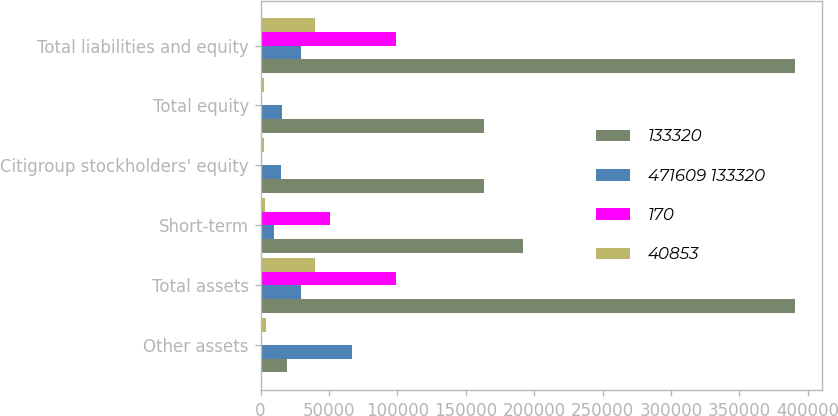Convert chart to OTSL. <chart><loc_0><loc_0><loc_500><loc_500><stacked_bar_chart><ecel><fcel>Other assets<fcel>Total assets<fcel>Short-term<fcel>Citigroup stockholders' equity<fcel>Total equity<fcel>Total liabilities and equity<nl><fcel>133320<fcel>19572<fcel>390607<fcel>191944<fcel>163468<fcel>163468<fcel>390607<nl><fcel>471609 133320<fcel>66467<fcel>29855.5<fcel>9566<fcel>15178<fcel>15593<fcel>29855.5<nl><fcel>170<fcel>561<fcel>99103<fcel>50629<fcel>1219<fcel>1219<fcel>99103<nl><fcel>40853<fcel>4318<fcel>40139<fcel>3396<fcel>2856<fcel>2856<fcel>40139<nl></chart> 